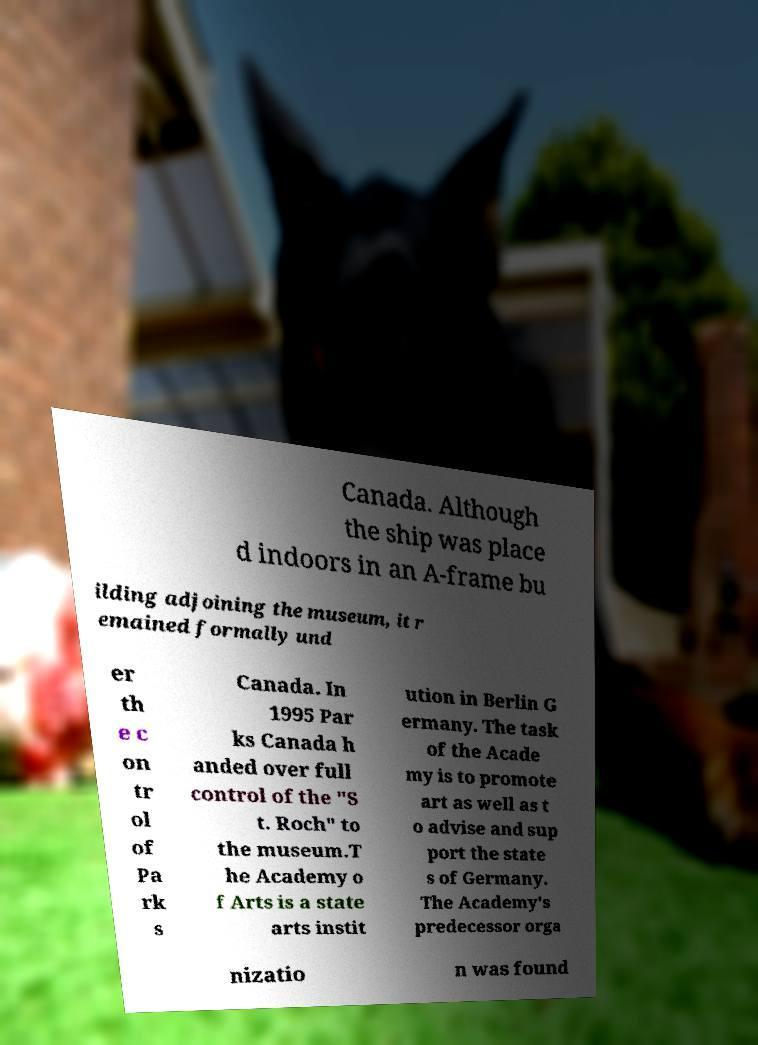Can you accurately transcribe the text from the provided image for me? Canada. Although the ship was place d indoors in an A-frame bu ilding adjoining the museum, it r emained formally und er th e c on tr ol of Pa rk s Canada. In 1995 Par ks Canada h anded over full control of the "S t. Roch" to the museum.T he Academy o f Arts is a state arts instit ution in Berlin G ermany. The task of the Acade my is to promote art as well as t o advise and sup port the state s of Germany. The Academy's predecessor orga nizatio n was found 